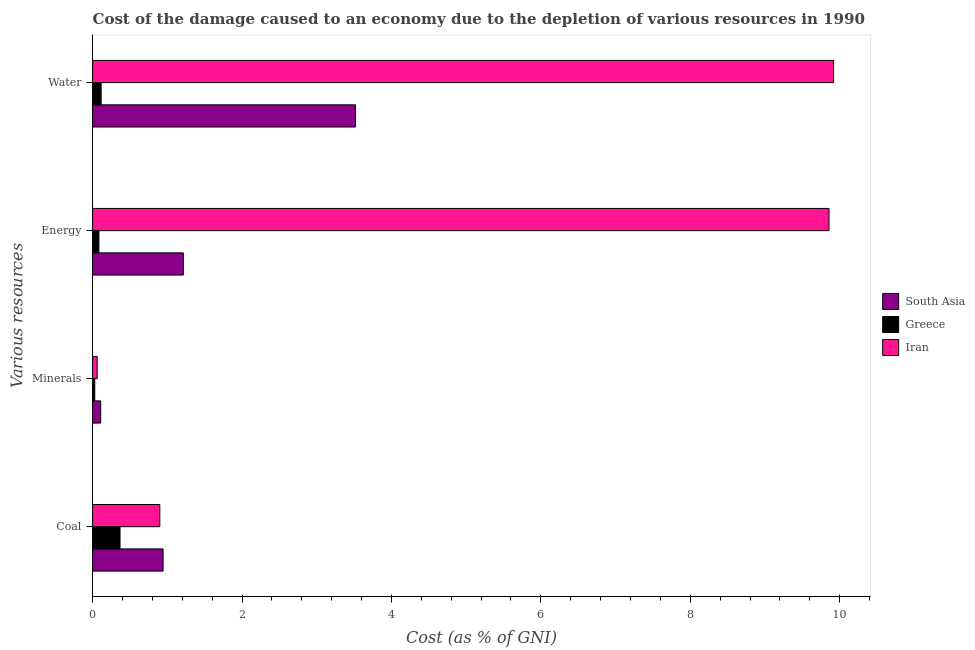How many bars are there on the 4th tick from the bottom?
Your response must be concise. 3. What is the label of the 2nd group of bars from the top?
Offer a very short reply. Energy. What is the cost of damage due to depletion of energy in South Asia?
Provide a succinct answer. 1.21. Across all countries, what is the maximum cost of damage due to depletion of water?
Your answer should be compact. 9.92. Across all countries, what is the minimum cost of damage due to depletion of water?
Make the answer very short. 0.11. What is the total cost of damage due to depletion of minerals in the graph?
Provide a short and direct response. 0.2. What is the difference between the cost of damage due to depletion of coal in Greece and that in Iran?
Ensure brevity in your answer.  -0.53. What is the difference between the cost of damage due to depletion of energy in Greece and the cost of damage due to depletion of coal in Iran?
Your answer should be very brief. -0.81. What is the average cost of damage due to depletion of water per country?
Provide a succinct answer. 4.52. What is the difference between the cost of damage due to depletion of minerals and cost of damage due to depletion of coal in Greece?
Your answer should be compact. -0.34. In how many countries, is the cost of damage due to depletion of minerals greater than 2.8 %?
Ensure brevity in your answer.  0. What is the ratio of the cost of damage due to depletion of minerals in Iran to that in Greece?
Provide a short and direct response. 2.09. Is the difference between the cost of damage due to depletion of coal in Greece and South Asia greater than the difference between the cost of damage due to depletion of energy in Greece and South Asia?
Your answer should be compact. Yes. What is the difference between the highest and the second highest cost of damage due to depletion of energy?
Offer a very short reply. 8.64. What is the difference between the highest and the lowest cost of damage due to depletion of minerals?
Your response must be concise. 0.08. Is it the case that in every country, the sum of the cost of damage due to depletion of minerals and cost of damage due to depletion of energy is greater than the sum of cost of damage due to depletion of water and cost of damage due to depletion of coal?
Give a very brief answer. No. Is it the case that in every country, the sum of the cost of damage due to depletion of coal and cost of damage due to depletion of minerals is greater than the cost of damage due to depletion of energy?
Provide a short and direct response. No. How many bars are there?
Keep it short and to the point. 12. How many countries are there in the graph?
Keep it short and to the point. 3. Does the graph contain any zero values?
Provide a short and direct response. No. Where does the legend appear in the graph?
Offer a very short reply. Center right. How many legend labels are there?
Ensure brevity in your answer.  3. What is the title of the graph?
Make the answer very short. Cost of the damage caused to an economy due to the depletion of various resources in 1990 . What is the label or title of the X-axis?
Your answer should be very brief. Cost (as % of GNI). What is the label or title of the Y-axis?
Ensure brevity in your answer.  Various resources. What is the Cost (as % of GNI) of South Asia in Coal?
Your answer should be compact. 0.94. What is the Cost (as % of GNI) of Greece in Coal?
Your response must be concise. 0.37. What is the Cost (as % of GNI) in Iran in Coal?
Ensure brevity in your answer.  0.9. What is the Cost (as % of GNI) of South Asia in Minerals?
Offer a very short reply. 0.11. What is the Cost (as % of GNI) in Greece in Minerals?
Your answer should be compact. 0.03. What is the Cost (as % of GNI) of Iran in Minerals?
Offer a terse response. 0.06. What is the Cost (as % of GNI) of South Asia in Energy?
Your answer should be very brief. 1.21. What is the Cost (as % of GNI) in Greece in Energy?
Your answer should be very brief. 0.09. What is the Cost (as % of GNI) of Iran in Energy?
Provide a succinct answer. 9.86. What is the Cost (as % of GNI) in South Asia in Water?
Your response must be concise. 3.52. What is the Cost (as % of GNI) of Greece in Water?
Your answer should be very brief. 0.11. What is the Cost (as % of GNI) of Iran in Water?
Give a very brief answer. 9.92. Across all Various resources, what is the maximum Cost (as % of GNI) in South Asia?
Offer a terse response. 3.52. Across all Various resources, what is the maximum Cost (as % of GNI) of Greece?
Your answer should be compact. 0.37. Across all Various resources, what is the maximum Cost (as % of GNI) of Iran?
Keep it short and to the point. 9.92. Across all Various resources, what is the minimum Cost (as % of GNI) of South Asia?
Your answer should be very brief. 0.11. Across all Various resources, what is the minimum Cost (as % of GNI) of Greece?
Offer a very short reply. 0.03. Across all Various resources, what is the minimum Cost (as % of GNI) of Iran?
Offer a very short reply. 0.06. What is the total Cost (as % of GNI) of South Asia in the graph?
Your answer should be compact. 5.79. What is the total Cost (as % of GNI) in Greece in the graph?
Make the answer very short. 0.6. What is the total Cost (as % of GNI) of Iran in the graph?
Your answer should be very brief. 20.74. What is the difference between the Cost (as % of GNI) of South Asia in Coal and that in Minerals?
Give a very brief answer. 0.84. What is the difference between the Cost (as % of GNI) of Greece in Coal and that in Minerals?
Ensure brevity in your answer.  0.34. What is the difference between the Cost (as % of GNI) in Iran in Coal and that in Minerals?
Give a very brief answer. 0.84. What is the difference between the Cost (as % of GNI) in South Asia in Coal and that in Energy?
Offer a terse response. -0.27. What is the difference between the Cost (as % of GNI) of Greece in Coal and that in Energy?
Offer a terse response. 0.28. What is the difference between the Cost (as % of GNI) in Iran in Coal and that in Energy?
Provide a succinct answer. -8.96. What is the difference between the Cost (as % of GNI) in South Asia in Coal and that in Water?
Offer a very short reply. -2.58. What is the difference between the Cost (as % of GNI) of Greece in Coal and that in Water?
Give a very brief answer. 0.25. What is the difference between the Cost (as % of GNI) of Iran in Coal and that in Water?
Make the answer very short. -9.02. What is the difference between the Cost (as % of GNI) of South Asia in Minerals and that in Energy?
Give a very brief answer. -1.11. What is the difference between the Cost (as % of GNI) of Greece in Minerals and that in Energy?
Your answer should be compact. -0.06. What is the difference between the Cost (as % of GNI) of Iran in Minerals and that in Energy?
Offer a very short reply. -9.79. What is the difference between the Cost (as % of GNI) in South Asia in Minerals and that in Water?
Your answer should be very brief. -3.41. What is the difference between the Cost (as % of GNI) of Greece in Minerals and that in Water?
Give a very brief answer. -0.09. What is the difference between the Cost (as % of GNI) in Iran in Minerals and that in Water?
Give a very brief answer. -9.86. What is the difference between the Cost (as % of GNI) in South Asia in Energy and that in Water?
Keep it short and to the point. -2.3. What is the difference between the Cost (as % of GNI) in Greece in Energy and that in Water?
Provide a succinct answer. -0.03. What is the difference between the Cost (as % of GNI) in Iran in Energy and that in Water?
Provide a succinct answer. -0.06. What is the difference between the Cost (as % of GNI) in South Asia in Coal and the Cost (as % of GNI) in Greece in Minerals?
Offer a terse response. 0.91. What is the difference between the Cost (as % of GNI) in South Asia in Coal and the Cost (as % of GNI) in Iran in Minerals?
Make the answer very short. 0.88. What is the difference between the Cost (as % of GNI) in Greece in Coal and the Cost (as % of GNI) in Iran in Minerals?
Your response must be concise. 0.31. What is the difference between the Cost (as % of GNI) in South Asia in Coal and the Cost (as % of GNI) in Greece in Energy?
Offer a terse response. 0.86. What is the difference between the Cost (as % of GNI) of South Asia in Coal and the Cost (as % of GNI) of Iran in Energy?
Your answer should be compact. -8.91. What is the difference between the Cost (as % of GNI) of Greece in Coal and the Cost (as % of GNI) of Iran in Energy?
Ensure brevity in your answer.  -9.49. What is the difference between the Cost (as % of GNI) of South Asia in Coal and the Cost (as % of GNI) of Greece in Water?
Ensure brevity in your answer.  0.83. What is the difference between the Cost (as % of GNI) in South Asia in Coal and the Cost (as % of GNI) in Iran in Water?
Offer a very short reply. -8.97. What is the difference between the Cost (as % of GNI) in Greece in Coal and the Cost (as % of GNI) in Iran in Water?
Keep it short and to the point. -9.55. What is the difference between the Cost (as % of GNI) of South Asia in Minerals and the Cost (as % of GNI) of Greece in Energy?
Keep it short and to the point. 0.02. What is the difference between the Cost (as % of GNI) of South Asia in Minerals and the Cost (as % of GNI) of Iran in Energy?
Your answer should be compact. -9.75. What is the difference between the Cost (as % of GNI) of Greece in Minerals and the Cost (as % of GNI) of Iran in Energy?
Provide a short and direct response. -9.83. What is the difference between the Cost (as % of GNI) of South Asia in Minerals and the Cost (as % of GNI) of Greece in Water?
Offer a terse response. -0.01. What is the difference between the Cost (as % of GNI) of South Asia in Minerals and the Cost (as % of GNI) of Iran in Water?
Keep it short and to the point. -9.81. What is the difference between the Cost (as % of GNI) of Greece in Minerals and the Cost (as % of GNI) of Iran in Water?
Make the answer very short. -9.89. What is the difference between the Cost (as % of GNI) of South Asia in Energy and the Cost (as % of GNI) of Greece in Water?
Offer a terse response. 1.1. What is the difference between the Cost (as % of GNI) of South Asia in Energy and the Cost (as % of GNI) of Iran in Water?
Provide a short and direct response. -8.7. What is the difference between the Cost (as % of GNI) of Greece in Energy and the Cost (as % of GNI) of Iran in Water?
Give a very brief answer. -9.83. What is the average Cost (as % of GNI) in South Asia per Various resources?
Provide a succinct answer. 1.45. What is the average Cost (as % of GNI) in Greece per Various resources?
Offer a very short reply. 0.15. What is the average Cost (as % of GNI) in Iran per Various resources?
Ensure brevity in your answer.  5.18. What is the difference between the Cost (as % of GNI) in South Asia and Cost (as % of GNI) in Greece in Coal?
Ensure brevity in your answer.  0.58. What is the difference between the Cost (as % of GNI) of South Asia and Cost (as % of GNI) of Iran in Coal?
Provide a succinct answer. 0.04. What is the difference between the Cost (as % of GNI) in Greece and Cost (as % of GNI) in Iran in Coal?
Keep it short and to the point. -0.53. What is the difference between the Cost (as % of GNI) in South Asia and Cost (as % of GNI) in Greece in Minerals?
Keep it short and to the point. 0.08. What is the difference between the Cost (as % of GNI) of South Asia and Cost (as % of GNI) of Iran in Minerals?
Provide a short and direct response. 0.05. What is the difference between the Cost (as % of GNI) of Greece and Cost (as % of GNI) of Iran in Minerals?
Your answer should be compact. -0.03. What is the difference between the Cost (as % of GNI) in South Asia and Cost (as % of GNI) in Greece in Energy?
Provide a succinct answer. 1.13. What is the difference between the Cost (as % of GNI) of South Asia and Cost (as % of GNI) of Iran in Energy?
Make the answer very short. -8.64. What is the difference between the Cost (as % of GNI) in Greece and Cost (as % of GNI) in Iran in Energy?
Your answer should be very brief. -9.77. What is the difference between the Cost (as % of GNI) in South Asia and Cost (as % of GNI) in Greece in Water?
Give a very brief answer. 3.4. What is the difference between the Cost (as % of GNI) in South Asia and Cost (as % of GNI) in Iran in Water?
Offer a terse response. -6.4. What is the difference between the Cost (as % of GNI) of Greece and Cost (as % of GNI) of Iran in Water?
Offer a terse response. -9.8. What is the ratio of the Cost (as % of GNI) in South Asia in Coal to that in Minerals?
Provide a succinct answer. 8.69. What is the ratio of the Cost (as % of GNI) in Greece in Coal to that in Minerals?
Keep it short and to the point. 12.45. What is the ratio of the Cost (as % of GNI) of Iran in Coal to that in Minerals?
Provide a succinct answer. 14.58. What is the ratio of the Cost (as % of GNI) of South Asia in Coal to that in Energy?
Offer a very short reply. 0.78. What is the ratio of the Cost (as % of GNI) in Greece in Coal to that in Energy?
Make the answer very short. 4.32. What is the ratio of the Cost (as % of GNI) of Iran in Coal to that in Energy?
Offer a very short reply. 0.09. What is the ratio of the Cost (as % of GNI) in South Asia in Coal to that in Water?
Offer a very short reply. 0.27. What is the ratio of the Cost (as % of GNI) in Greece in Coal to that in Water?
Offer a very short reply. 3.21. What is the ratio of the Cost (as % of GNI) of Iran in Coal to that in Water?
Offer a terse response. 0.09. What is the ratio of the Cost (as % of GNI) in South Asia in Minerals to that in Energy?
Offer a very short reply. 0.09. What is the ratio of the Cost (as % of GNI) of Greece in Minerals to that in Energy?
Ensure brevity in your answer.  0.35. What is the ratio of the Cost (as % of GNI) of Iran in Minerals to that in Energy?
Offer a terse response. 0.01. What is the ratio of the Cost (as % of GNI) in South Asia in Minerals to that in Water?
Provide a short and direct response. 0.03. What is the ratio of the Cost (as % of GNI) in Greece in Minerals to that in Water?
Your answer should be very brief. 0.26. What is the ratio of the Cost (as % of GNI) of Iran in Minerals to that in Water?
Your response must be concise. 0.01. What is the ratio of the Cost (as % of GNI) in South Asia in Energy to that in Water?
Provide a succinct answer. 0.35. What is the ratio of the Cost (as % of GNI) in Greece in Energy to that in Water?
Your response must be concise. 0.74. What is the ratio of the Cost (as % of GNI) of Iran in Energy to that in Water?
Offer a terse response. 0.99. What is the difference between the highest and the second highest Cost (as % of GNI) in South Asia?
Give a very brief answer. 2.3. What is the difference between the highest and the second highest Cost (as % of GNI) of Greece?
Provide a succinct answer. 0.25. What is the difference between the highest and the second highest Cost (as % of GNI) in Iran?
Give a very brief answer. 0.06. What is the difference between the highest and the lowest Cost (as % of GNI) in South Asia?
Make the answer very short. 3.41. What is the difference between the highest and the lowest Cost (as % of GNI) in Greece?
Offer a terse response. 0.34. What is the difference between the highest and the lowest Cost (as % of GNI) of Iran?
Provide a succinct answer. 9.86. 